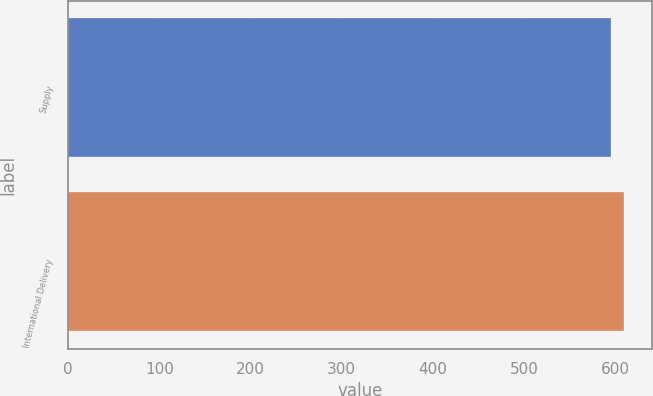Convert chart to OTSL. <chart><loc_0><loc_0><loc_500><loc_500><bar_chart><fcel>Supply<fcel>International Delivery<nl><fcel>595<fcel>610<nl></chart> 